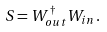<formula> <loc_0><loc_0><loc_500><loc_500>S = W _ { o u t } ^ { \dagger } W _ { i n } \, .</formula> 